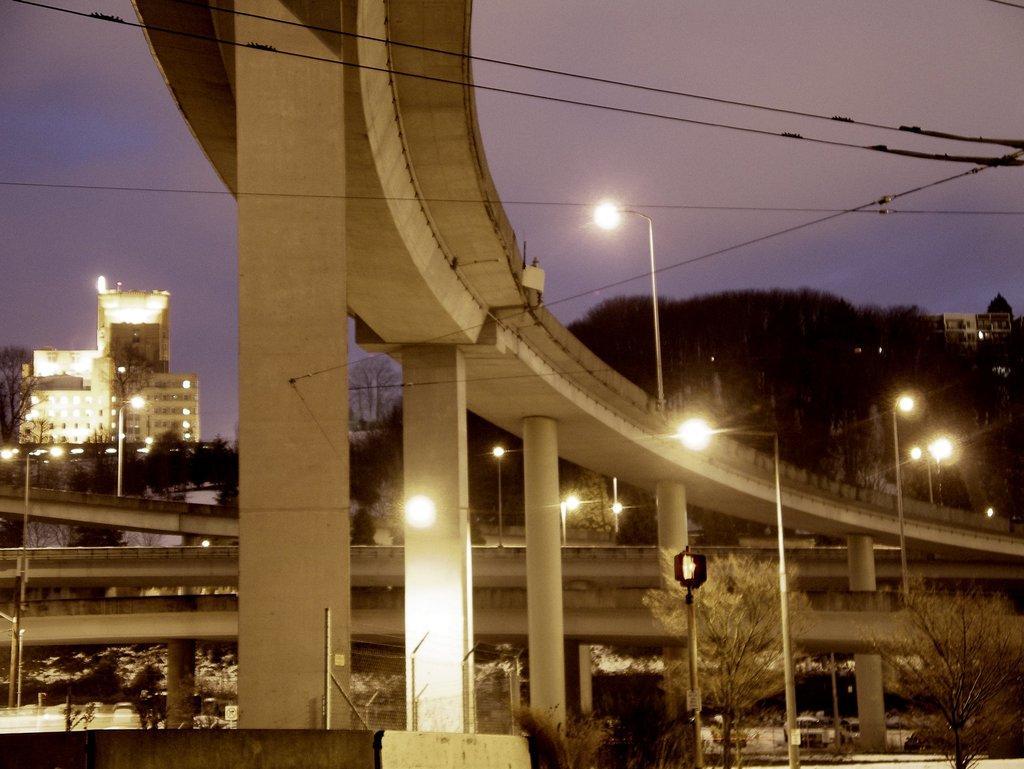In one or two sentences, can you explain what this image depicts? There is a bridge in the middle of this image and there are some trees and building in the background. There are some lights on the right side of this image. There is a sky on the top of this image. 